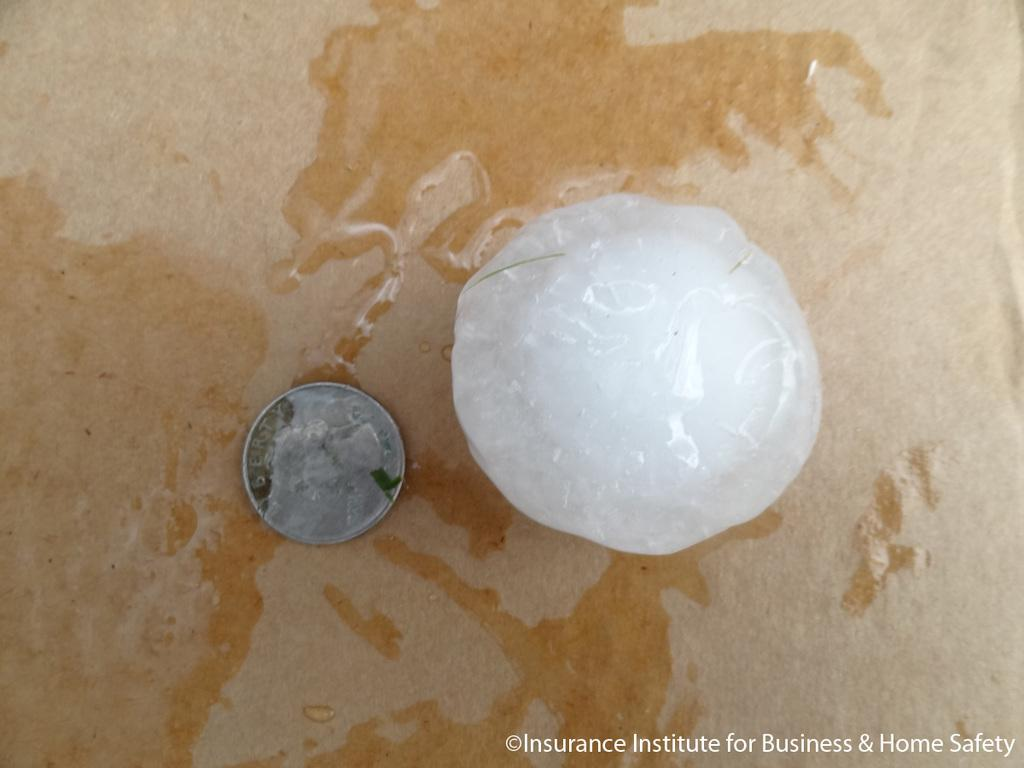<image>
Provide a brief description of the given image. A nickel sits next to a piece of hail in a picture by the Insurance Institute for Business and Safety. 